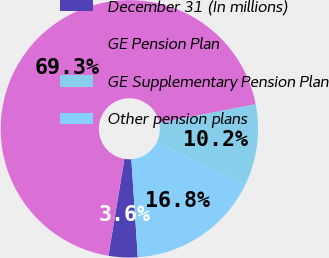<chart> <loc_0><loc_0><loc_500><loc_500><pie_chart><fcel>December 31 (In millions)<fcel>GE Pension Plan<fcel>GE Supplementary Pension Plan<fcel>Other pension plans<nl><fcel>3.65%<fcel>69.35%<fcel>10.22%<fcel>16.79%<nl></chart> 